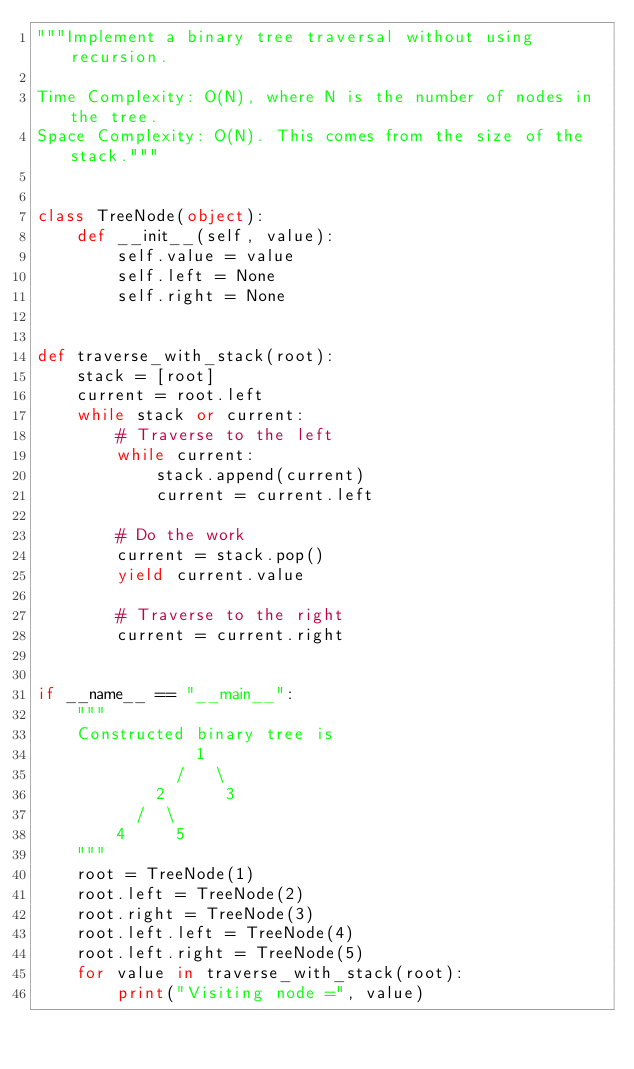<code> <loc_0><loc_0><loc_500><loc_500><_Python_>"""Implement a binary tree traversal without using recursion.

Time Complexity: O(N), where N is the number of nodes in the tree.
Space Complexity: O(N). This comes from the size of the stack."""


class TreeNode(object):
    def __init__(self, value):
        self.value = value
        self.left = None
        self.right = None


def traverse_with_stack(root):
    stack = [root]
    current = root.left
    while stack or current:
        # Traverse to the left
        while current:
            stack.append(current)
            current = current.left

        # Do the work
        current = stack.pop()
        yield current.value

        # Traverse to the right
        current = current.right


if __name__ == "__main__":
    """ 
    Constructed binary tree is
                1
              /   \
            2      3
          /  \
        4     5
    """
    root = TreeNode(1)
    root.left = TreeNode(2)
    root.right = TreeNode(3)
    root.left.left = TreeNode(4)
    root.left.right = TreeNode(5)
    for value in traverse_with_stack(root):
        print("Visiting node =", value)

</code> 